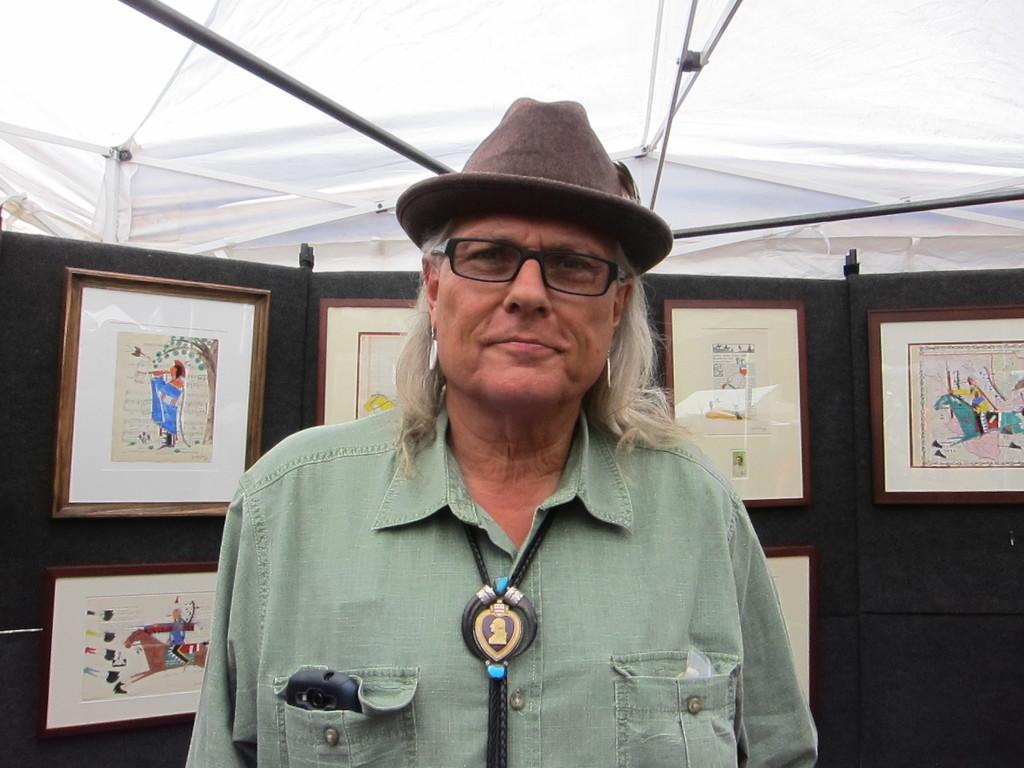Describe this image in one or two sentences. In the picture we can see a man standing and he is in the green shirt and long hair and hat and behind them, we can see a wall with photo frames and paintings on it and two of it, we can see a white color and on top of it we can see a white color tent with a rod to it. 